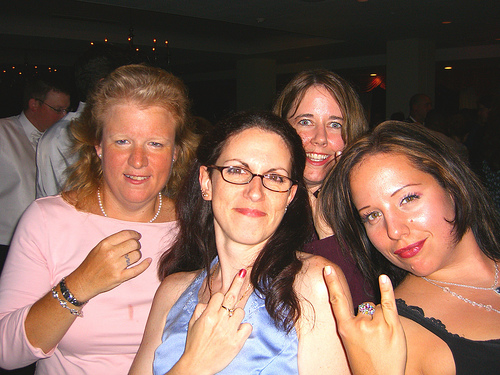<image>
Is there a big women to the right of the small women? Yes. From this viewpoint, the big women is positioned to the right side relative to the small women. 